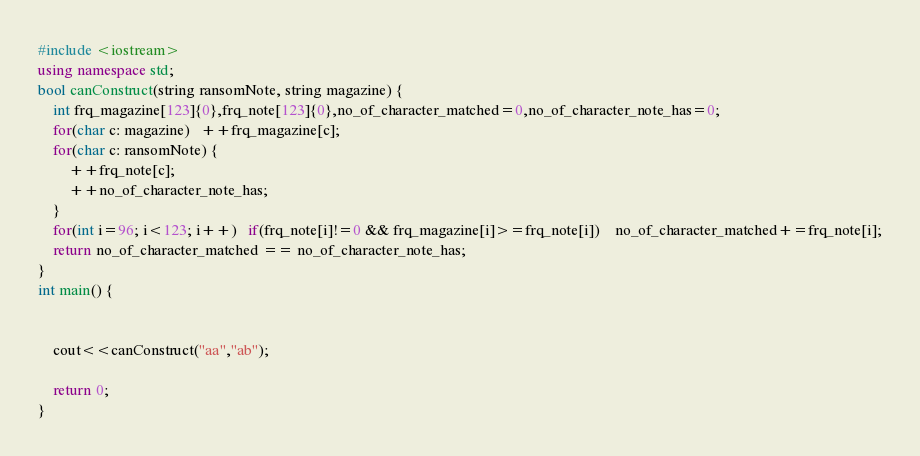Convert code to text. <code><loc_0><loc_0><loc_500><loc_500><_C++_>#include <iostream>
using namespace std;
bool canConstruct(string ransomNote, string magazine) {
    int frq_magazine[123]{0},frq_note[123]{0},no_of_character_matched=0,no_of_character_note_has=0;
    for(char c: magazine)   ++frq_magazine[c];
    for(char c: ransomNote) {
        ++frq_note[c];
        ++no_of_character_note_has;
    }
    for(int i=96; i<123; i++)   if(frq_note[i]!=0 && frq_magazine[i]>=frq_note[i])    no_of_character_matched+=frq_note[i];
    return no_of_character_matched == no_of_character_note_has;
}
int main() {


    cout<<canConstruct("aa","ab");

    return 0;
}</code> 